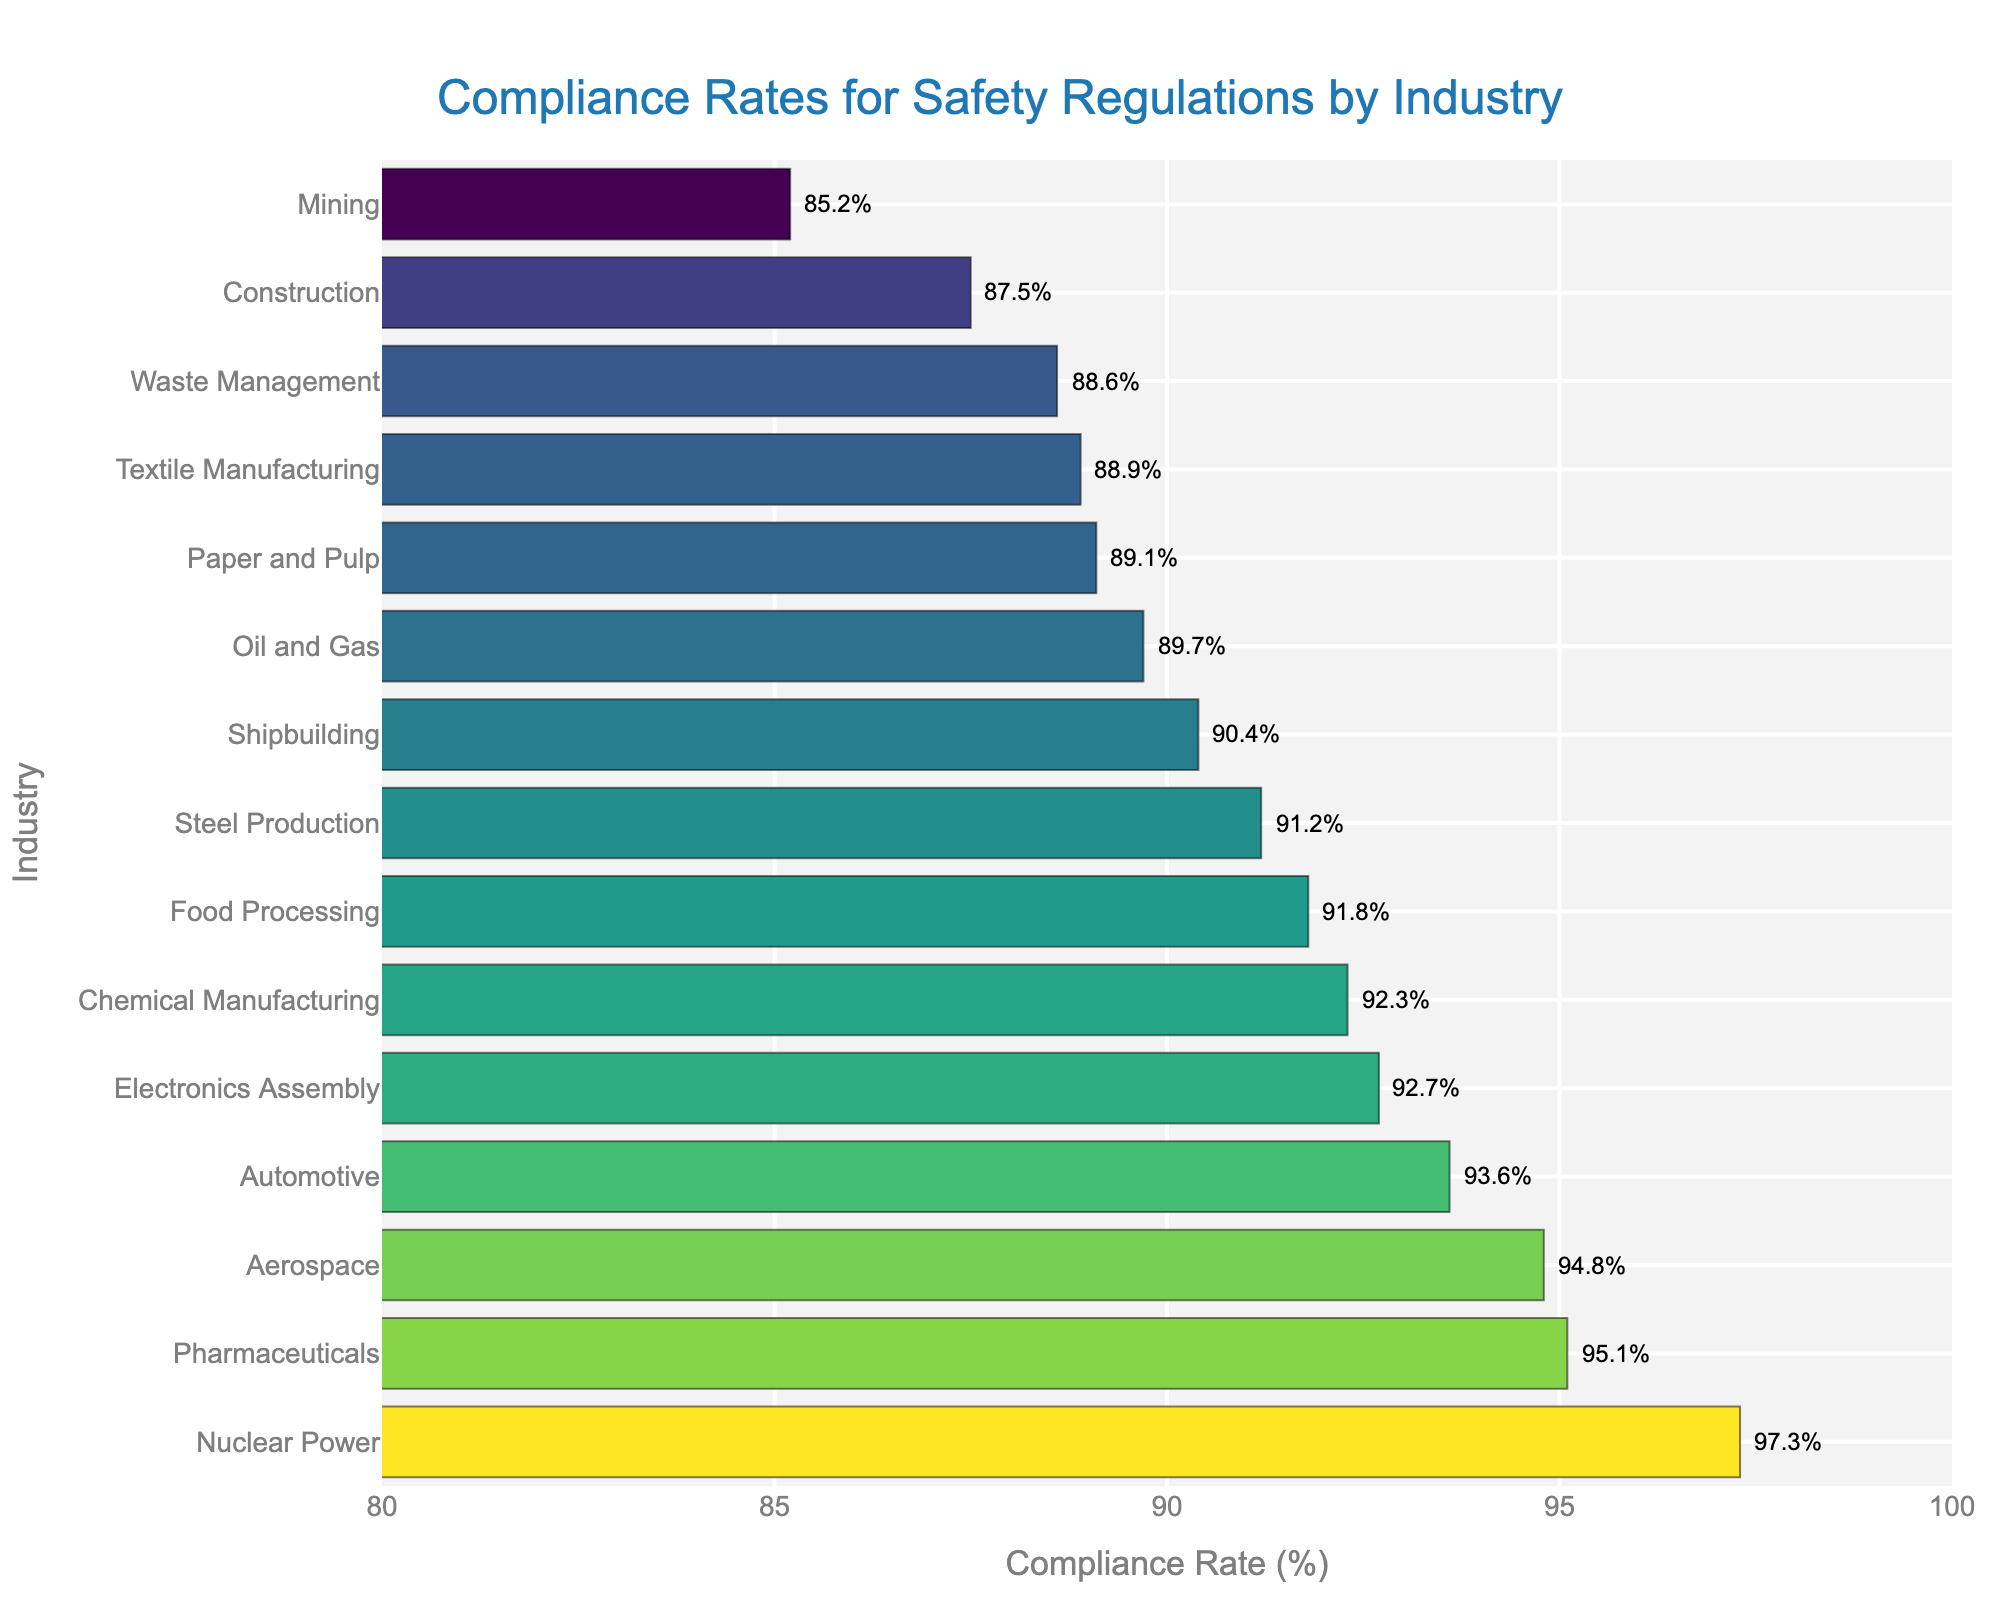What is the compliance rate for the Nuclear Power industry? Locate the Nuclear Power industry on the y-axis and refer to the corresponding bar on the x-axis to see the compliance rate.
Answer: 97.3% Which industry has the lowest compliance rate? Identify the shortest bar and follow it to the y-axis to find the corresponding industry.
Answer: Mining How much higher is the compliance rate of Pharmaceuticals compared to Waste Management? Find the compliance rates for Pharmaceuticals (95.1%) and Waste Management (88.6%), then subtract the latter from the former (95.1% - 88.6%).
Answer: 6.5% Which industries have a compliance rate greater than 90%? Find all the bars extending past the 90% mark on the x-axis and check their corresponding industries on the y-axis.
Answer: Chemical Manufacturing, Food Processing, Automotive, Pharmaceuticals, Aerospace, Electronics Assembly, Shipbuilding, Steel Production, Nuclear Power What is the average compliance rate among all industries listed? Sum all the compliance rates and divide by the number of industries (Sum: 1318.4% / 15 industries).
Answer: 87.89% Is the compliance rate of Construction closer to that of Textile Manufacturing or Waste Management? Compare the compliance rate of Construction (87.5%) with Textile Manufacturing (88.9%) and Waste Management (88.6%); see which difference is smaller. Construction to Textile Manufacturing: 1.4%; Construction to Waste Management: 1.1%.
Answer: Waste Management What is the range of compliance rates in the dataset? Find the difference between the highest compliance rate (Nuclear Power, 97.3%) and the lowest compliance rate (Mining, 85.2%).
Answer: 12.1% Which industry has a higher compliance rate: Electronics Assembly or Paper and Pulp? Locate both industries on the y-axis and compare the lengths of their bars on the x-axis.
Answer: Electronics Assembly How many industries have compliance rates between 85% and 90%? Identify and count all the bars that fall within the range of 85% to 90% on the x-axis: Construction, Oil and Gas, Mining, Textile Manufacturing, Shipbuilding, and Paper and Pulp.
Answer: 6 What is the median compliance rate? Sort all compliance rates in ascending order and find the middle value. The sorted values are: 85.2, 87.5, 88.6, 88.9, 89.1, 89.7, 90.4, 91.2, 91.8, 92.3, 92.7, 93.6, 94.8, 95.1, 97.3. The middle (8th) value is 91.2%.
Answer: 91.2% 